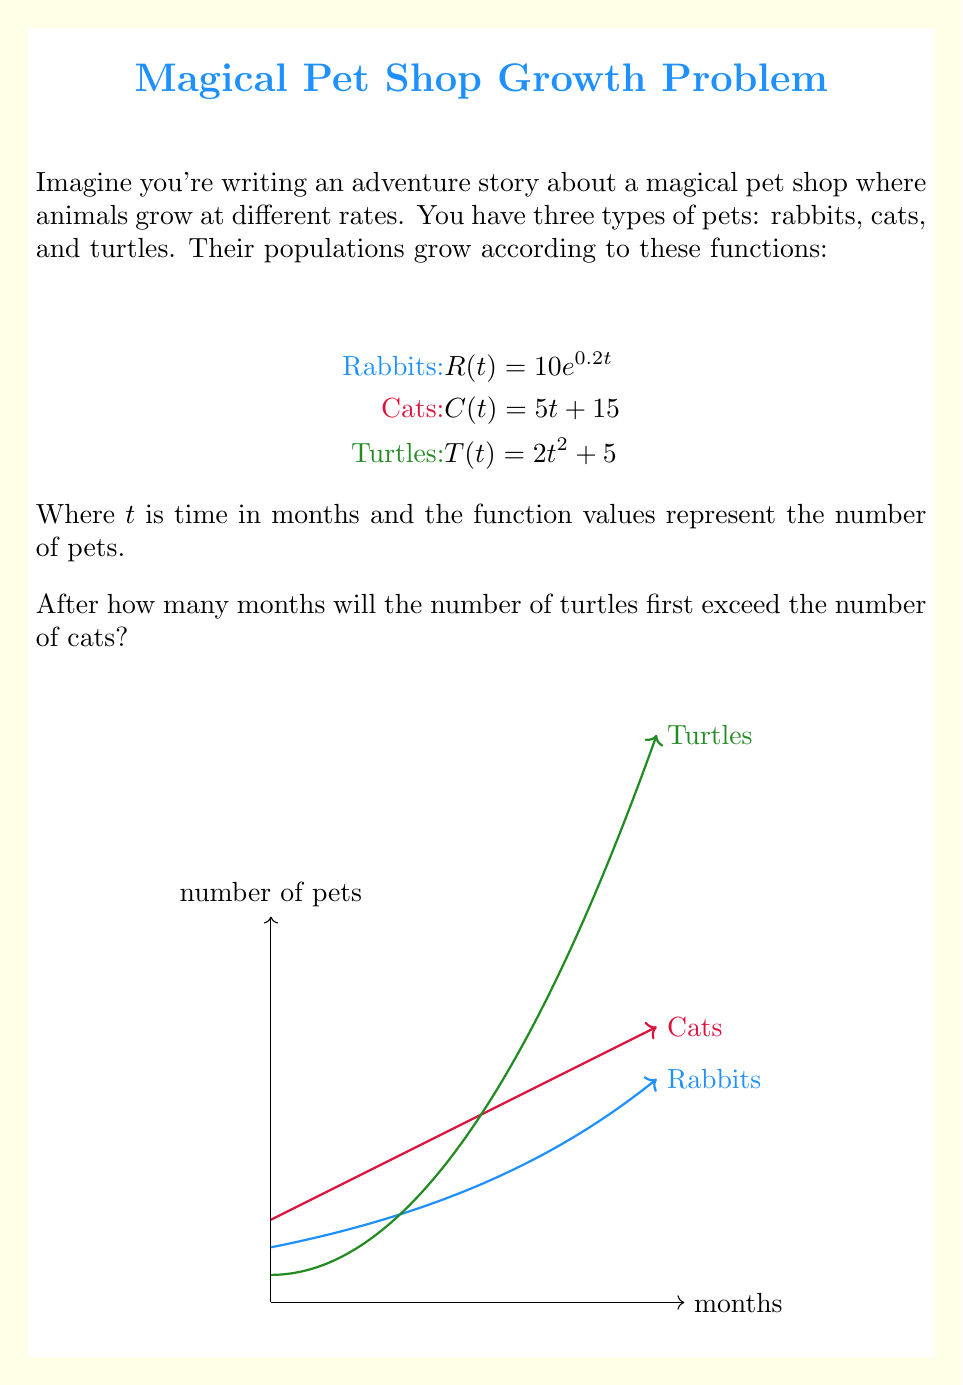Can you solve this math problem? Let's approach this step-by-step:

1) We need to find when the number of turtles equals the number of cats. This means solving the equation:

   $T(t) = C(t)$

2) Substituting the functions:

   $2t^2 + 5 = 5t + 15$

3) Rearranging the equation:

   $2t^2 - 5t - 10 = 0$

4) This is a quadratic equation. We can solve it using the quadratic formula:
   
   $t = \frac{-b \pm \sqrt{b^2 - 4ac}}{2a}$

   Where $a=2$, $b=-5$, and $c=-10$

5) Plugging in these values:

   $t = \frac{5 \pm \sqrt{(-5)^2 - 4(2)(-10)}}{2(2)}$
   
   $= \frac{5 \pm \sqrt{25 + 80}}{4} = \frac{5 \pm \sqrt{105}}{4}$

6) This gives us two solutions:

   $t_1 = \frac{5 + \sqrt{105}}{4} \approx 3.81$ months
   $t_2 = \frac{5 - \sqrt{105}}{4} \approx -1.31$ months

7) Since time can't be negative, we discard the negative solution.

8) The positive solution isn't a whole number, so we need to round up to the next month.
Answer: 4 months 